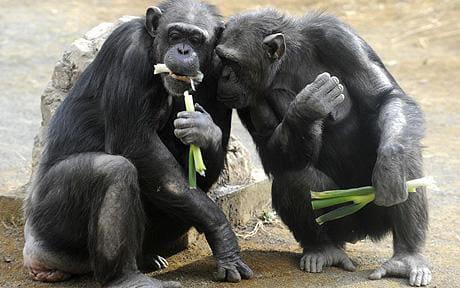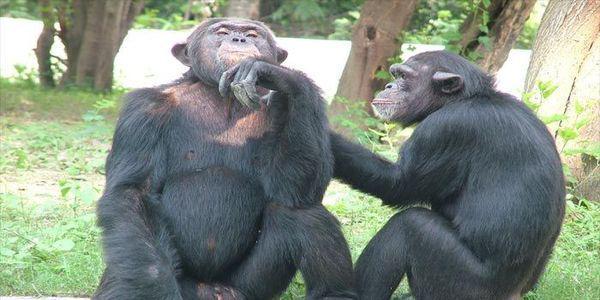The first image is the image on the left, the second image is the image on the right. For the images displayed, is the sentence "Two primates sit in a grassy area in the image on the right." factually correct? Answer yes or no. Yes. The first image is the image on the left, the second image is the image on the right. For the images displayed, is the sentence "An image shows a pair of squatting apes that each hold a food-type item in one hand." factually correct? Answer yes or no. Yes. 